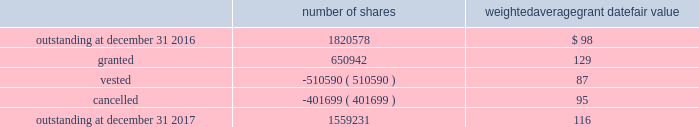In 2017 , the company granted 440076 shares of restricted class a common stock and 7568 shares of restricted stock units .
Restricted common stock and restricted stock units generally have a vesting period of two to four years .
The fair value related to these grants was $ 58.7 million , which is recognized as compensation expense on an accelerated basis over the vesting period .
Dividends are accrued on restricted class a common stock and restricted stock units and are paid once the restricted stock vests .
In 2017 , the company also granted 203298 performance shares .
The fair value related to these grants was $ 25.3 million , which is recognized as compensation expense on an accelerated and straight-lined basis over the vesting period .
The vesting of these shares is contingent on meeting stated performance or market conditions .
The table summarizes restricted stock , restricted stock units , and performance shares activity for 2017 : number of shares weighted average grant date fair value .
The total fair value of restricted stock , restricted stock units , and performance shares that vested during 2017 , 2016 and 2015 was $ 66.0 million , $ 59.8 million and $ 43.3 million , respectively .
Under the espp , eligible employees may acquire shares of class a common stock using after-tax payroll deductions made during consecutive offering periods of approximately six months in duration .
Shares are purchased at the end of each offering period at a price of 90% ( 90 % ) of the closing price of the class a common stock as reported on the nasdaq global select market .
Compensation expense is recognized on the dates of purchase for the discount from the closing price .
In 2017 , 2016 and 2015 , a total of 19936 , 19858 and 19756 shares , respectively , of class a common stock were issued to participating employees .
These shares are subject to a six-month holding period .
Annual expense of $ 0.3 million for the purchase discount was recognized in 2017 , and $ 0.2 million was recognized in both 2016 and 2015 .
Non-executive directors receive an annual award of class a common stock with a value equal to $ 100000 .
Non-executive directors may also elect to receive some or all of the cash portion of their annual stipend , up to $ 60000 , in shares of stock based on the closing price at the date of distribution .
As a result , 19736 shares , 26439 shares and 25853 shares of class a common stock were issued to non-executive directors during 2017 , 2016 and 2015 , respectively .
These shares are not subject to any vesting restrictions .
Expense of $ 2.5 million , $ 2.4 million and $ 2.5 million related to these stock-based payments was recognized for the years ended december 31 , 2017 , 2016 and 2015 , respectively. .
Based on the review of the restricted stock , restricted stock units , and performance shares activity for 2017 what was the percentage change on the outstanding stock? 
Computations: ((1559231 - 1820578) / 1820578)
Answer: -0.14355. 